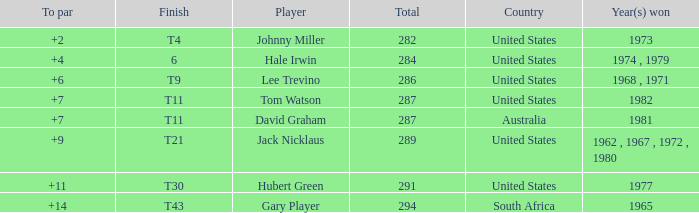WHAT IS THE TO PAR WITH A FINISH OF T11, FOR DAVID GRAHAM? 7.0. 